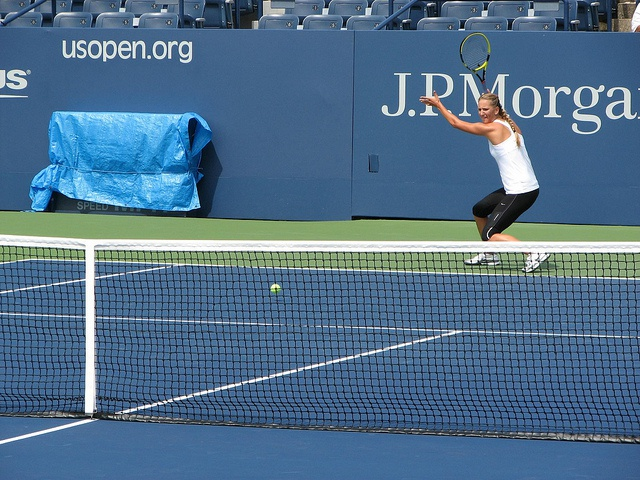Describe the objects in this image and their specific colors. I can see people in gray, white, black, and tan tones, chair in gray, blue, and navy tones, tennis racket in gray and blue tones, chair in gray, navy, blue, and black tones, and chair in gray, blue, and darkgray tones in this image. 